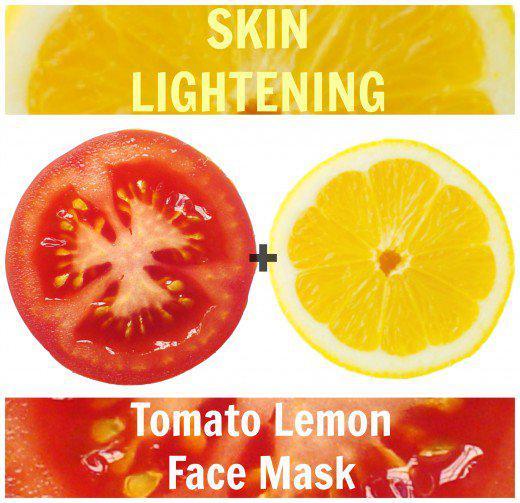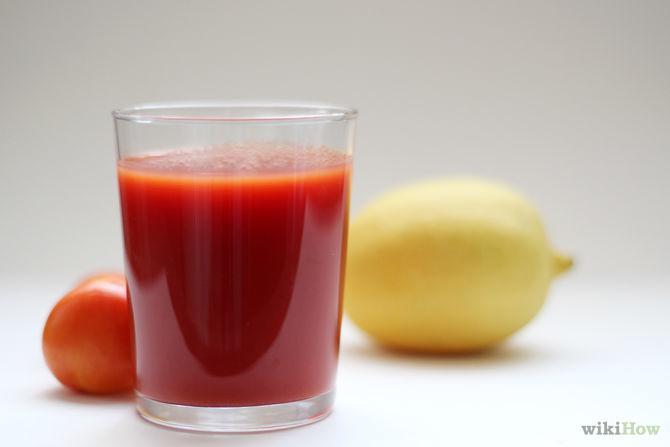The first image is the image on the left, the second image is the image on the right. Analyze the images presented: Is the assertion "One image includes a non-jar type glass containing reddish-orange liquid, along with a whole tomato and a whole lemon." valid? Answer yes or no. Yes. The first image is the image on the left, the second image is the image on the right. Examine the images to the left and right. Is the description "One of the images features a glass of tomato juice." accurate? Answer yes or no. Yes. 